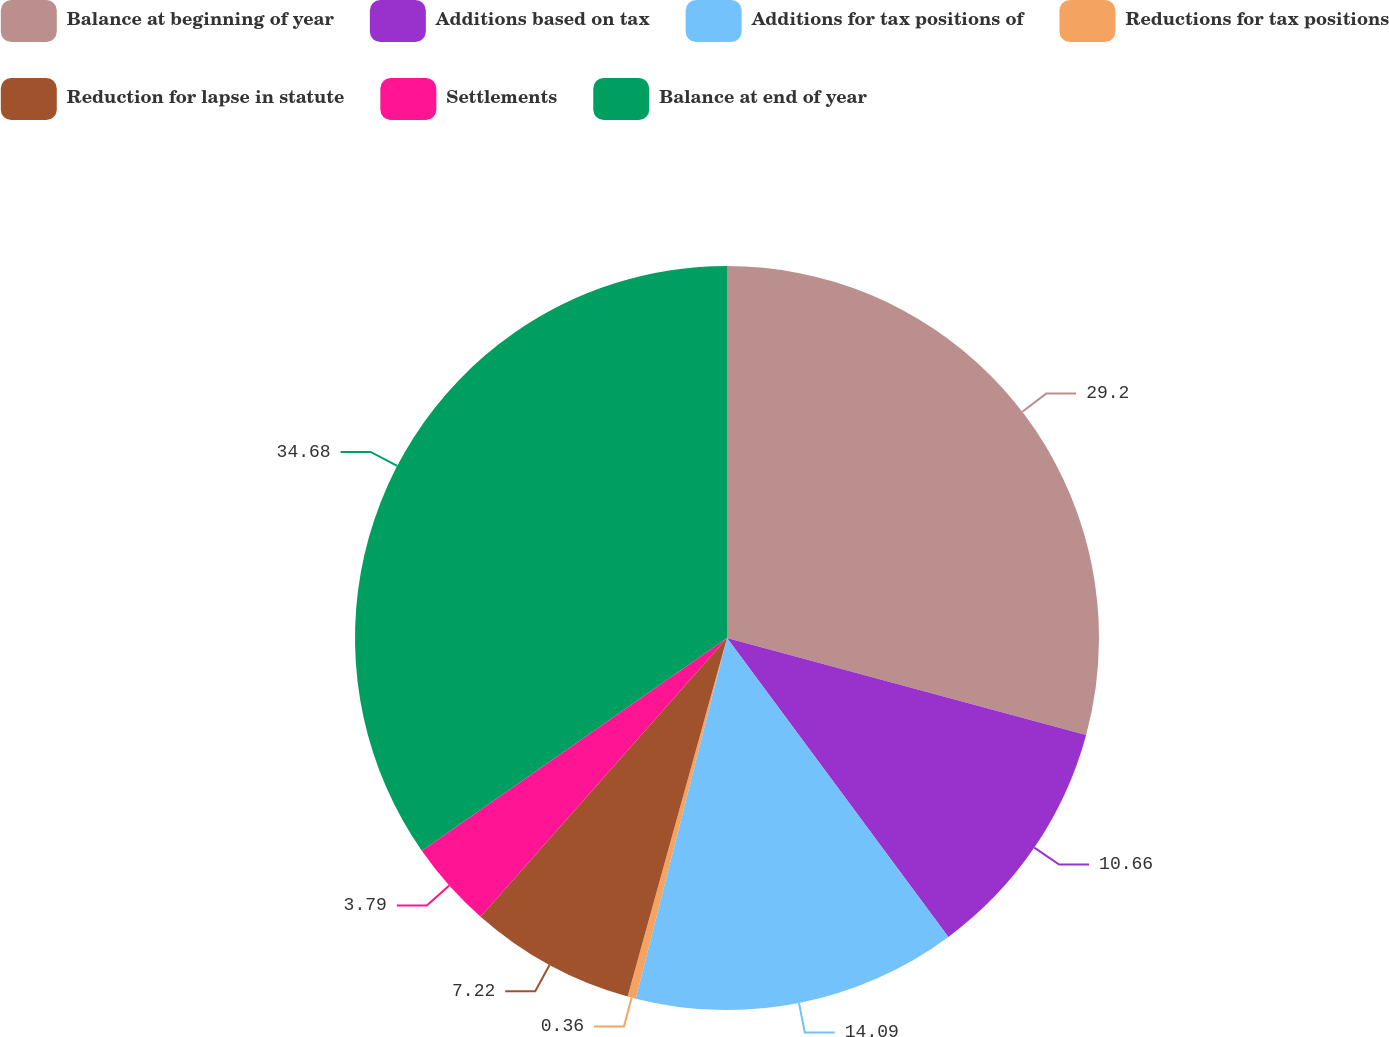<chart> <loc_0><loc_0><loc_500><loc_500><pie_chart><fcel>Balance at beginning of year<fcel>Additions based on tax<fcel>Additions for tax positions of<fcel>Reductions for tax positions<fcel>Reduction for lapse in statute<fcel>Settlements<fcel>Balance at end of year<nl><fcel>29.2%<fcel>10.66%<fcel>14.09%<fcel>0.36%<fcel>7.22%<fcel>3.79%<fcel>34.69%<nl></chart> 